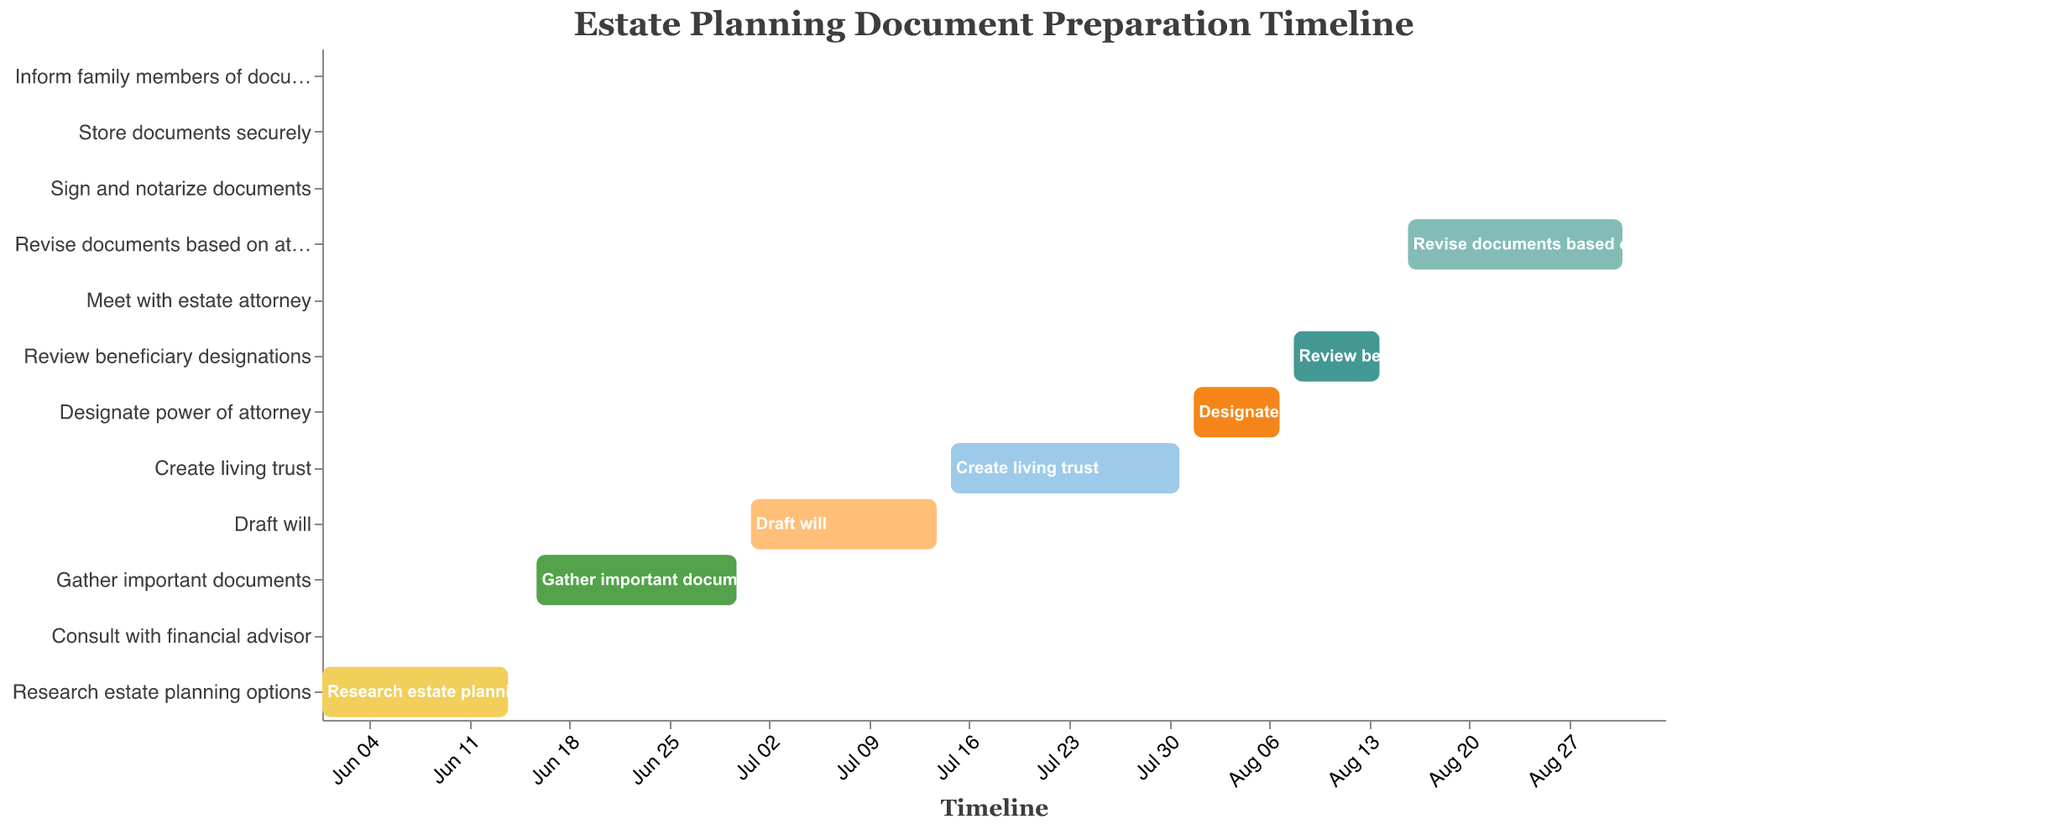What is the title of the chart? The title of the chart is displayed at the top in a larger font, which reads "Estate Planning Document Preparation Timeline"
Answer: Estate Planning Document Preparation Timeline Which task spans the longest duration? To determine this, we look at the difference between the start and end dates for each task. "Revise documents based on attorney feedback" from 2023-08-16 to 2023-08-31 spans 16 days, which is the longest.
Answer: Revise documents based on attorney feedback What are the start and end dates for drafting the will? The Gantt chart shows the "Draft will" task as starting on 2023-07-01 and ending on 2023-07-14. These dates are directly derived from the bar representing this task.
Answer: 2023-07-01 to 2023-07-14 How many tasks are scheduled to end in September? By inspecting the end dates in the Gantt chart, we see that three tasks ("Sign and notarize documents" on 2023-09-01, "Store documents securely" on 2023-09-02, and "Inform family members of document locations" on 2023-09-03) have end dates in September.
Answer: 3 Do any tasks overlap in August? By observing the Gantt chart, we see that the tasks "Designate power of attorney" (ending on 2023-08-07) and "Review beneficiary designations" (starting on 2023-08-08) are sequential. However, "Revise documents based on attorney feedback" (from 2023-08-16 to 2023-08-31) overlaps with "Meet with estate attorney" (on 2023-08-15).
Answer: Yes Which task comes immediately after gathering important documents? By looking at the timeline, the task "Draft will" starts on 2023-07-01, right after "Gather important documents" ends on 2023-06-30.
Answer: Draft will Which task requires consulting with a professional, and when is it scheduled? By noting the related task descriptions, "Consult with financial advisor" on 2023-06-15 requires consulting a professional. Additionally, "Meet with estate attorney" on 2023-08-15 also requires professional consultation.
Answer: Consult with financial advisor on 2023-06-15, Meet with estate attorney on 2023-08-15 What is the total duration from the start of the first task to the end of the last task? The first task "Research estate planning options" starts on 2023-06-01 and the last task "Inform family members of document locations" ends on 2023-09-03. Calculating the total duration involves counting the days from 2023-06-01 to 2023-09-03, which is 95 days in total.
Answer: 95 days Which task has the shortest duration? By comparing the durations of all tasks, "Consult with financial advisor", "Meet with estate attorney", "Sign and notarize documents", "Store documents securely", and "Inform family members of document locations" all take just 1 day.
Answer: Consult with financial advisor, Meet with estate attorney, Sign and notarize documents, Store documents securely, Inform family members of document locations On which date should you meet with the estate attorney? According to the Gantt chart, the task "Meet with estate attorney" is scheduled for only one day on 2023-08-15.
Answer: 2023-08-15 